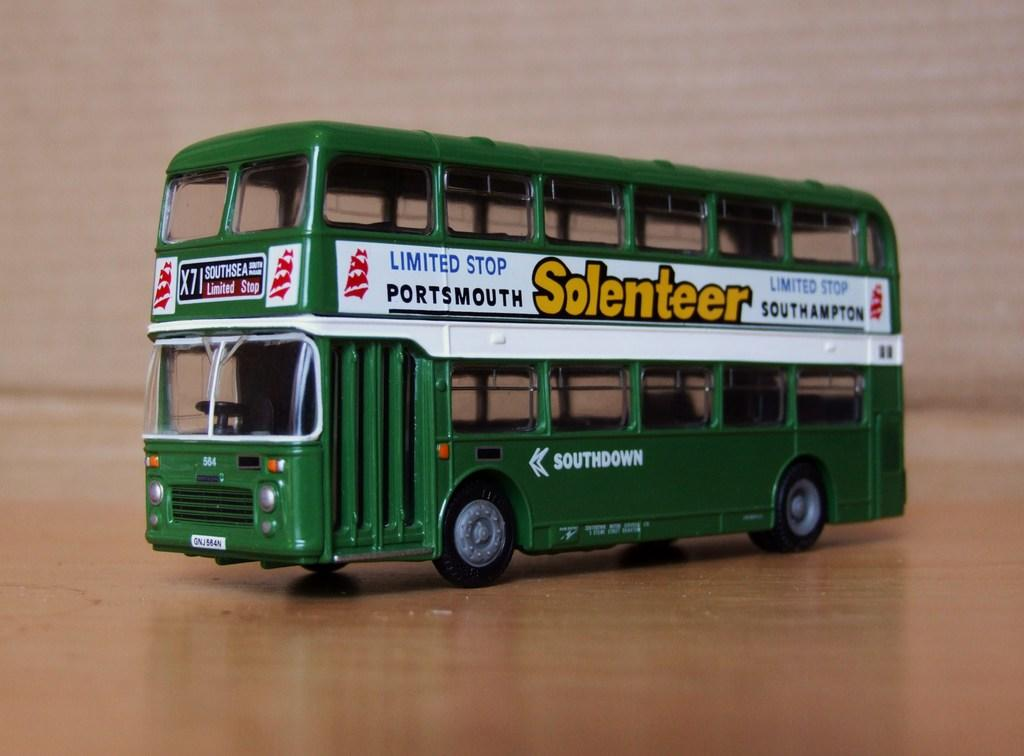What type of object is in the image? There is a toy vehicle in the image. What is the toy vehicle resting on? The toy vehicle is on a wooden surface. What can be seen behind the toy vehicle? The background of the image is visible. Can you see any goldfish swimming in the image? No, there are no goldfish present in the image. 